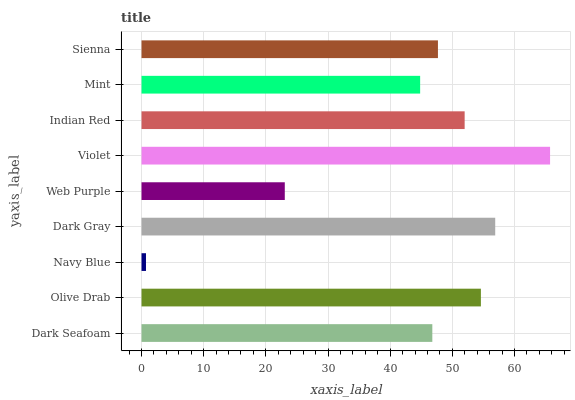Is Navy Blue the minimum?
Answer yes or no. Yes. Is Violet the maximum?
Answer yes or no. Yes. Is Olive Drab the minimum?
Answer yes or no. No. Is Olive Drab the maximum?
Answer yes or no. No. Is Olive Drab greater than Dark Seafoam?
Answer yes or no. Yes. Is Dark Seafoam less than Olive Drab?
Answer yes or no. Yes. Is Dark Seafoam greater than Olive Drab?
Answer yes or no. No. Is Olive Drab less than Dark Seafoam?
Answer yes or no. No. Is Sienna the high median?
Answer yes or no. Yes. Is Sienna the low median?
Answer yes or no. Yes. Is Violet the high median?
Answer yes or no. No. Is Mint the low median?
Answer yes or no. No. 